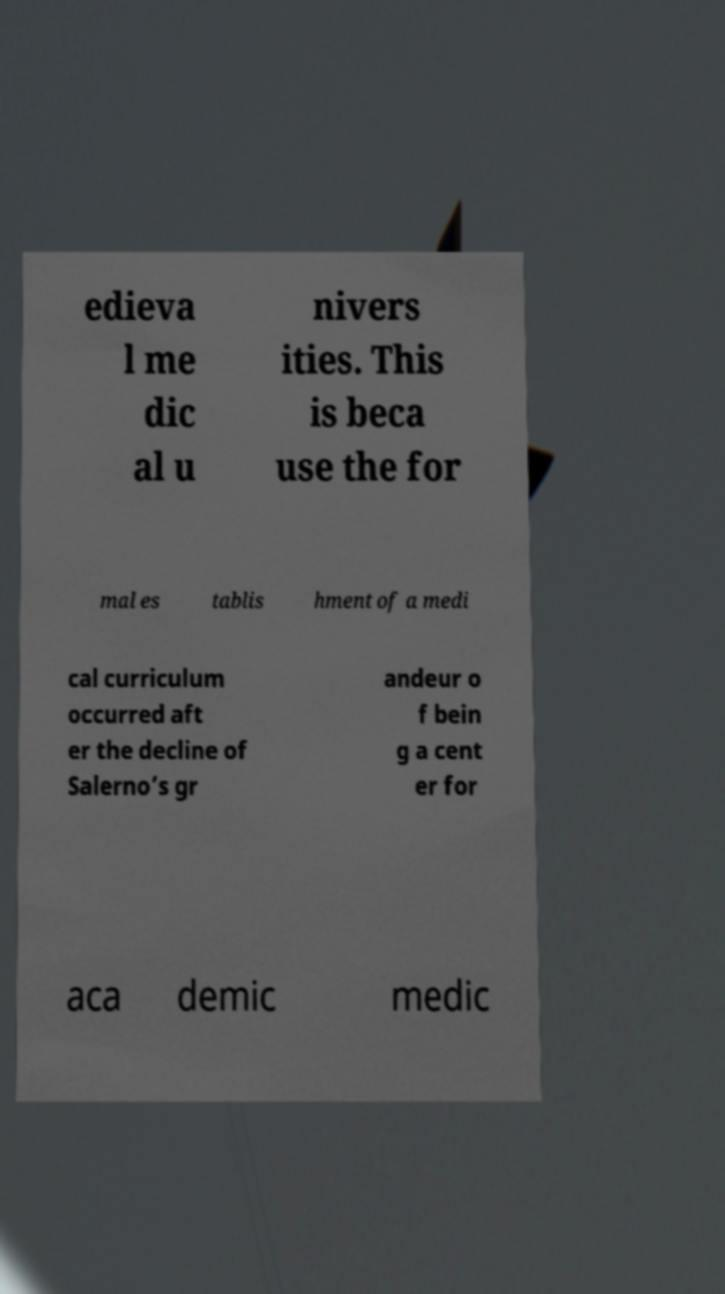I need the written content from this picture converted into text. Can you do that? edieva l me dic al u nivers ities. This is beca use the for mal es tablis hment of a medi cal curriculum occurred aft er the decline of Salerno’s gr andeur o f bein g a cent er for aca demic medic 